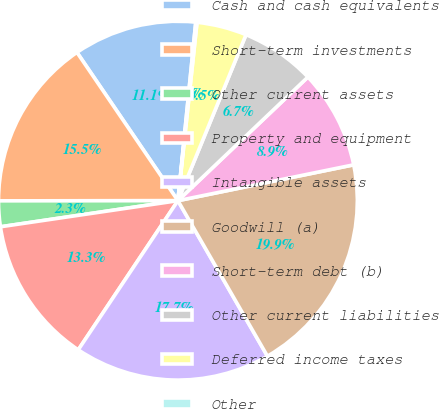Convert chart to OTSL. <chart><loc_0><loc_0><loc_500><loc_500><pie_chart><fcel>Cash and cash equivalents<fcel>Short-term investments<fcel>Other current assets<fcel>Property and equipment<fcel>Intangible assets<fcel>Goodwill (a)<fcel>Short-term debt (b)<fcel>Other current liabilities<fcel>Deferred income taxes<fcel>Other<nl><fcel>11.1%<fcel>15.5%<fcel>2.31%<fcel>13.3%<fcel>17.69%<fcel>19.89%<fcel>8.9%<fcel>6.7%<fcel>4.5%<fcel>0.11%<nl></chart> 